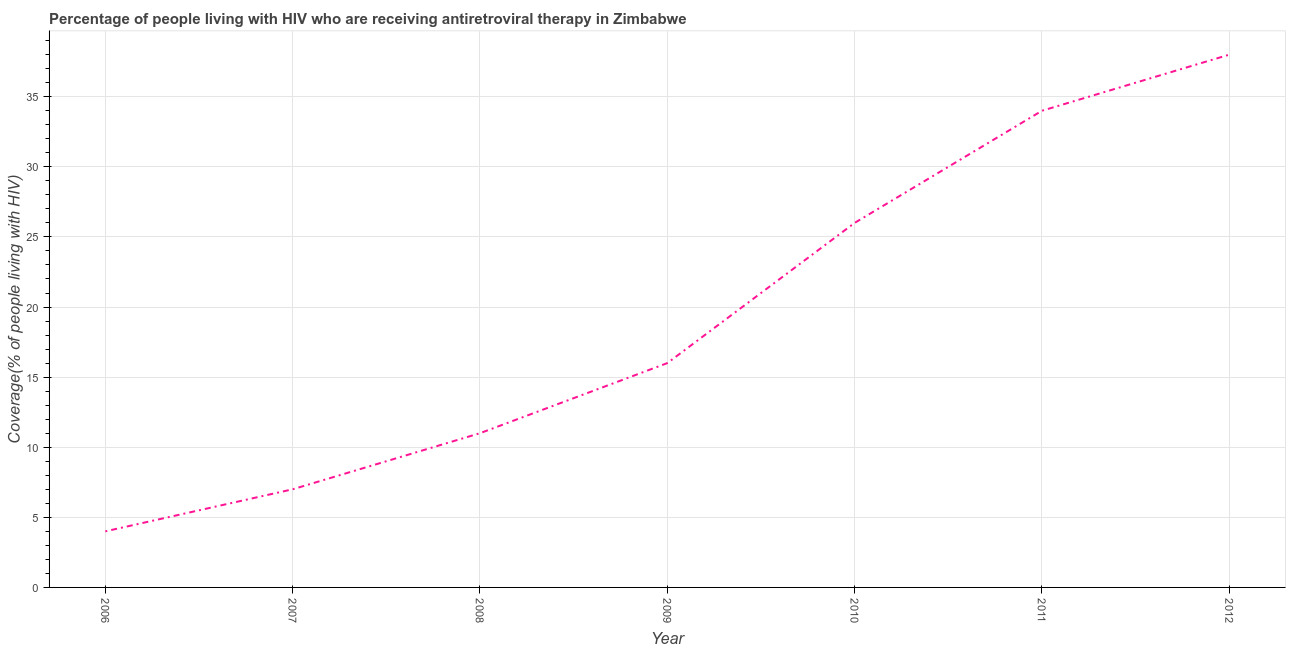What is the antiretroviral therapy coverage in 2011?
Keep it short and to the point. 34. Across all years, what is the maximum antiretroviral therapy coverage?
Make the answer very short. 38. Across all years, what is the minimum antiretroviral therapy coverage?
Provide a short and direct response. 4. What is the sum of the antiretroviral therapy coverage?
Provide a short and direct response. 136. What is the difference between the antiretroviral therapy coverage in 2006 and 2008?
Your response must be concise. -7. What is the average antiretroviral therapy coverage per year?
Provide a succinct answer. 19.43. In how many years, is the antiretroviral therapy coverage greater than 27 %?
Provide a short and direct response. 2. What is the ratio of the antiretroviral therapy coverage in 2007 to that in 2008?
Provide a short and direct response. 0.64. Is the difference between the antiretroviral therapy coverage in 2009 and 2011 greater than the difference between any two years?
Offer a very short reply. No. What is the difference between the highest and the second highest antiretroviral therapy coverage?
Offer a terse response. 4. Is the sum of the antiretroviral therapy coverage in 2009 and 2011 greater than the maximum antiretroviral therapy coverage across all years?
Make the answer very short. Yes. What is the difference between the highest and the lowest antiretroviral therapy coverage?
Provide a short and direct response. 34. In how many years, is the antiretroviral therapy coverage greater than the average antiretroviral therapy coverage taken over all years?
Offer a very short reply. 3. How many lines are there?
Keep it short and to the point. 1. What is the difference between two consecutive major ticks on the Y-axis?
Provide a short and direct response. 5. Are the values on the major ticks of Y-axis written in scientific E-notation?
Give a very brief answer. No. Does the graph contain grids?
Keep it short and to the point. Yes. What is the title of the graph?
Your answer should be compact. Percentage of people living with HIV who are receiving antiretroviral therapy in Zimbabwe. What is the label or title of the X-axis?
Offer a terse response. Year. What is the label or title of the Y-axis?
Give a very brief answer. Coverage(% of people living with HIV). What is the Coverage(% of people living with HIV) of 2007?
Ensure brevity in your answer.  7. What is the Coverage(% of people living with HIV) of 2008?
Give a very brief answer. 11. What is the Coverage(% of people living with HIV) of 2009?
Ensure brevity in your answer.  16. What is the Coverage(% of people living with HIV) in 2010?
Your answer should be very brief. 26. What is the difference between the Coverage(% of people living with HIV) in 2006 and 2007?
Provide a succinct answer. -3. What is the difference between the Coverage(% of people living with HIV) in 2006 and 2008?
Offer a very short reply. -7. What is the difference between the Coverage(% of people living with HIV) in 2006 and 2009?
Offer a very short reply. -12. What is the difference between the Coverage(% of people living with HIV) in 2006 and 2011?
Offer a very short reply. -30. What is the difference between the Coverage(% of people living with HIV) in 2006 and 2012?
Ensure brevity in your answer.  -34. What is the difference between the Coverage(% of people living with HIV) in 2007 and 2011?
Your answer should be compact. -27. What is the difference between the Coverage(% of people living with HIV) in 2007 and 2012?
Ensure brevity in your answer.  -31. What is the difference between the Coverage(% of people living with HIV) in 2008 and 2010?
Offer a terse response. -15. What is the difference between the Coverage(% of people living with HIV) in 2008 and 2011?
Keep it short and to the point. -23. What is the difference between the Coverage(% of people living with HIV) in 2008 and 2012?
Offer a terse response. -27. What is the difference between the Coverage(% of people living with HIV) in 2009 and 2010?
Ensure brevity in your answer.  -10. What is the difference between the Coverage(% of people living with HIV) in 2009 and 2012?
Offer a very short reply. -22. What is the difference between the Coverage(% of people living with HIV) in 2010 and 2011?
Offer a very short reply. -8. What is the difference between the Coverage(% of people living with HIV) in 2010 and 2012?
Offer a terse response. -12. What is the difference between the Coverage(% of people living with HIV) in 2011 and 2012?
Provide a succinct answer. -4. What is the ratio of the Coverage(% of people living with HIV) in 2006 to that in 2007?
Make the answer very short. 0.57. What is the ratio of the Coverage(% of people living with HIV) in 2006 to that in 2008?
Ensure brevity in your answer.  0.36. What is the ratio of the Coverage(% of people living with HIV) in 2006 to that in 2010?
Your answer should be compact. 0.15. What is the ratio of the Coverage(% of people living with HIV) in 2006 to that in 2011?
Your answer should be very brief. 0.12. What is the ratio of the Coverage(% of people living with HIV) in 2006 to that in 2012?
Provide a succinct answer. 0.1. What is the ratio of the Coverage(% of people living with HIV) in 2007 to that in 2008?
Your response must be concise. 0.64. What is the ratio of the Coverage(% of people living with HIV) in 2007 to that in 2009?
Offer a very short reply. 0.44. What is the ratio of the Coverage(% of people living with HIV) in 2007 to that in 2010?
Your answer should be compact. 0.27. What is the ratio of the Coverage(% of people living with HIV) in 2007 to that in 2011?
Your response must be concise. 0.21. What is the ratio of the Coverage(% of people living with HIV) in 2007 to that in 2012?
Make the answer very short. 0.18. What is the ratio of the Coverage(% of people living with HIV) in 2008 to that in 2009?
Your answer should be compact. 0.69. What is the ratio of the Coverage(% of people living with HIV) in 2008 to that in 2010?
Provide a succinct answer. 0.42. What is the ratio of the Coverage(% of people living with HIV) in 2008 to that in 2011?
Your response must be concise. 0.32. What is the ratio of the Coverage(% of people living with HIV) in 2008 to that in 2012?
Your answer should be very brief. 0.29. What is the ratio of the Coverage(% of people living with HIV) in 2009 to that in 2010?
Your answer should be compact. 0.61. What is the ratio of the Coverage(% of people living with HIV) in 2009 to that in 2011?
Offer a very short reply. 0.47. What is the ratio of the Coverage(% of people living with HIV) in 2009 to that in 2012?
Give a very brief answer. 0.42. What is the ratio of the Coverage(% of people living with HIV) in 2010 to that in 2011?
Make the answer very short. 0.77. What is the ratio of the Coverage(% of people living with HIV) in 2010 to that in 2012?
Make the answer very short. 0.68. What is the ratio of the Coverage(% of people living with HIV) in 2011 to that in 2012?
Provide a short and direct response. 0.9. 